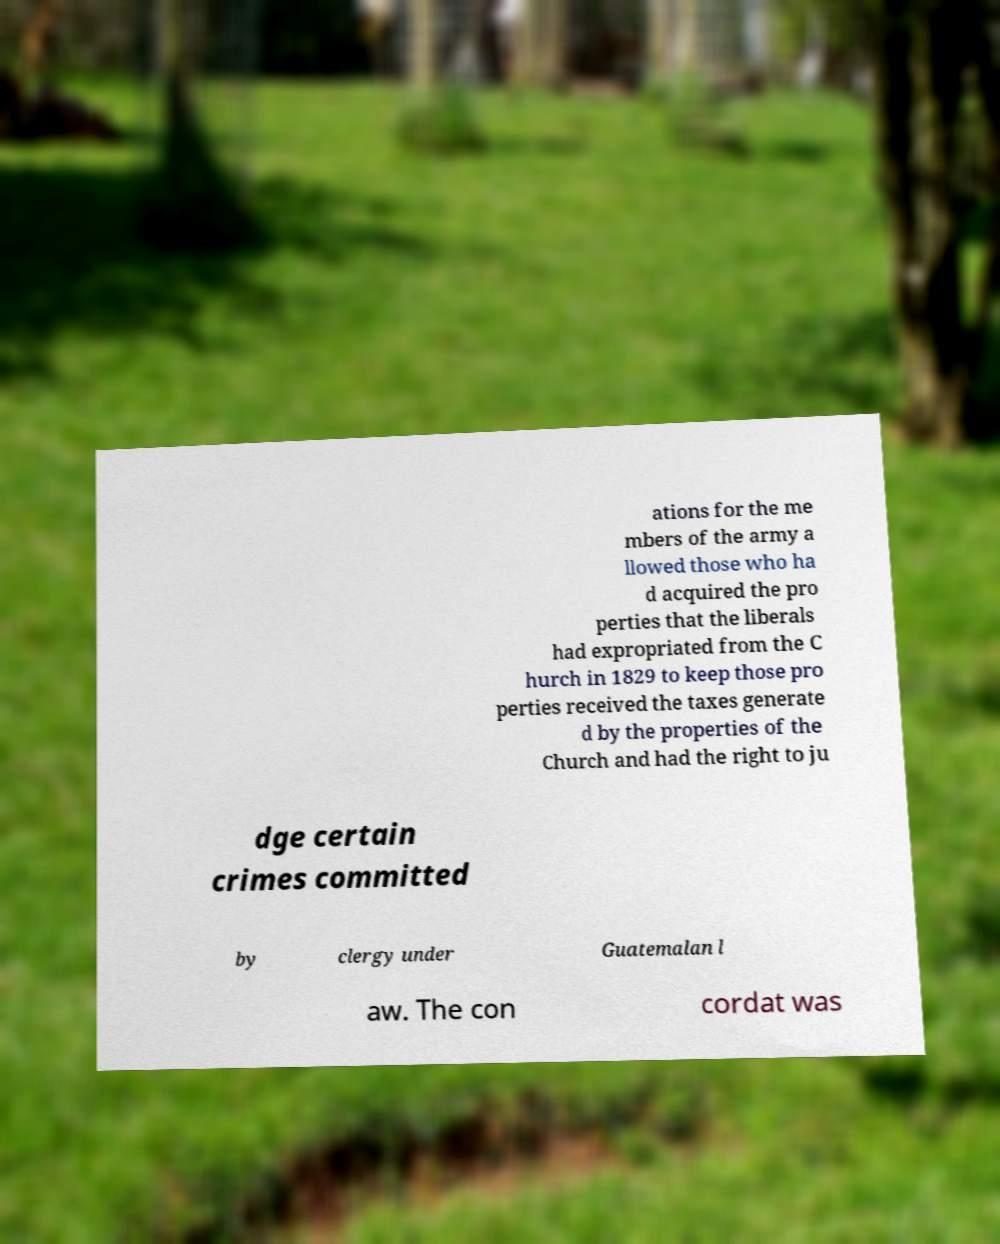There's text embedded in this image that I need extracted. Can you transcribe it verbatim? ations for the me mbers of the army a llowed those who ha d acquired the pro perties that the liberals had expropriated from the C hurch in 1829 to keep those pro perties received the taxes generate d by the properties of the Church and had the right to ju dge certain crimes committed by clergy under Guatemalan l aw. The con cordat was 